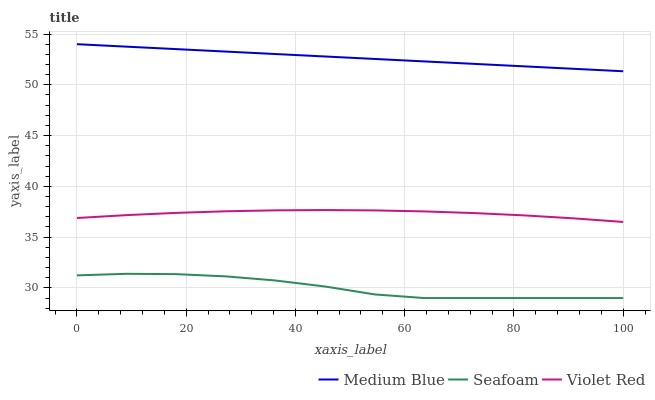Does Seafoam have the minimum area under the curve?
Answer yes or no. Yes. Does Medium Blue have the maximum area under the curve?
Answer yes or no. Yes. Does Medium Blue have the minimum area under the curve?
Answer yes or no. No. Does Seafoam have the maximum area under the curve?
Answer yes or no. No. Is Medium Blue the smoothest?
Answer yes or no. Yes. Is Seafoam the roughest?
Answer yes or no. Yes. Is Seafoam the smoothest?
Answer yes or no. No. Is Medium Blue the roughest?
Answer yes or no. No. Does Medium Blue have the lowest value?
Answer yes or no. No. Does Medium Blue have the highest value?
Answer yes or no. Yes. Does Seafoam have the highest value?
Answer yes or no. No. Is Seafoam less than Violet Red?
Answer yes or no. Yes. Is Medium Blue greater than Violet Red?
Answer yes or no. Yes. Does Seafoam intersect Violet Red?
Answer yes or no. No. 